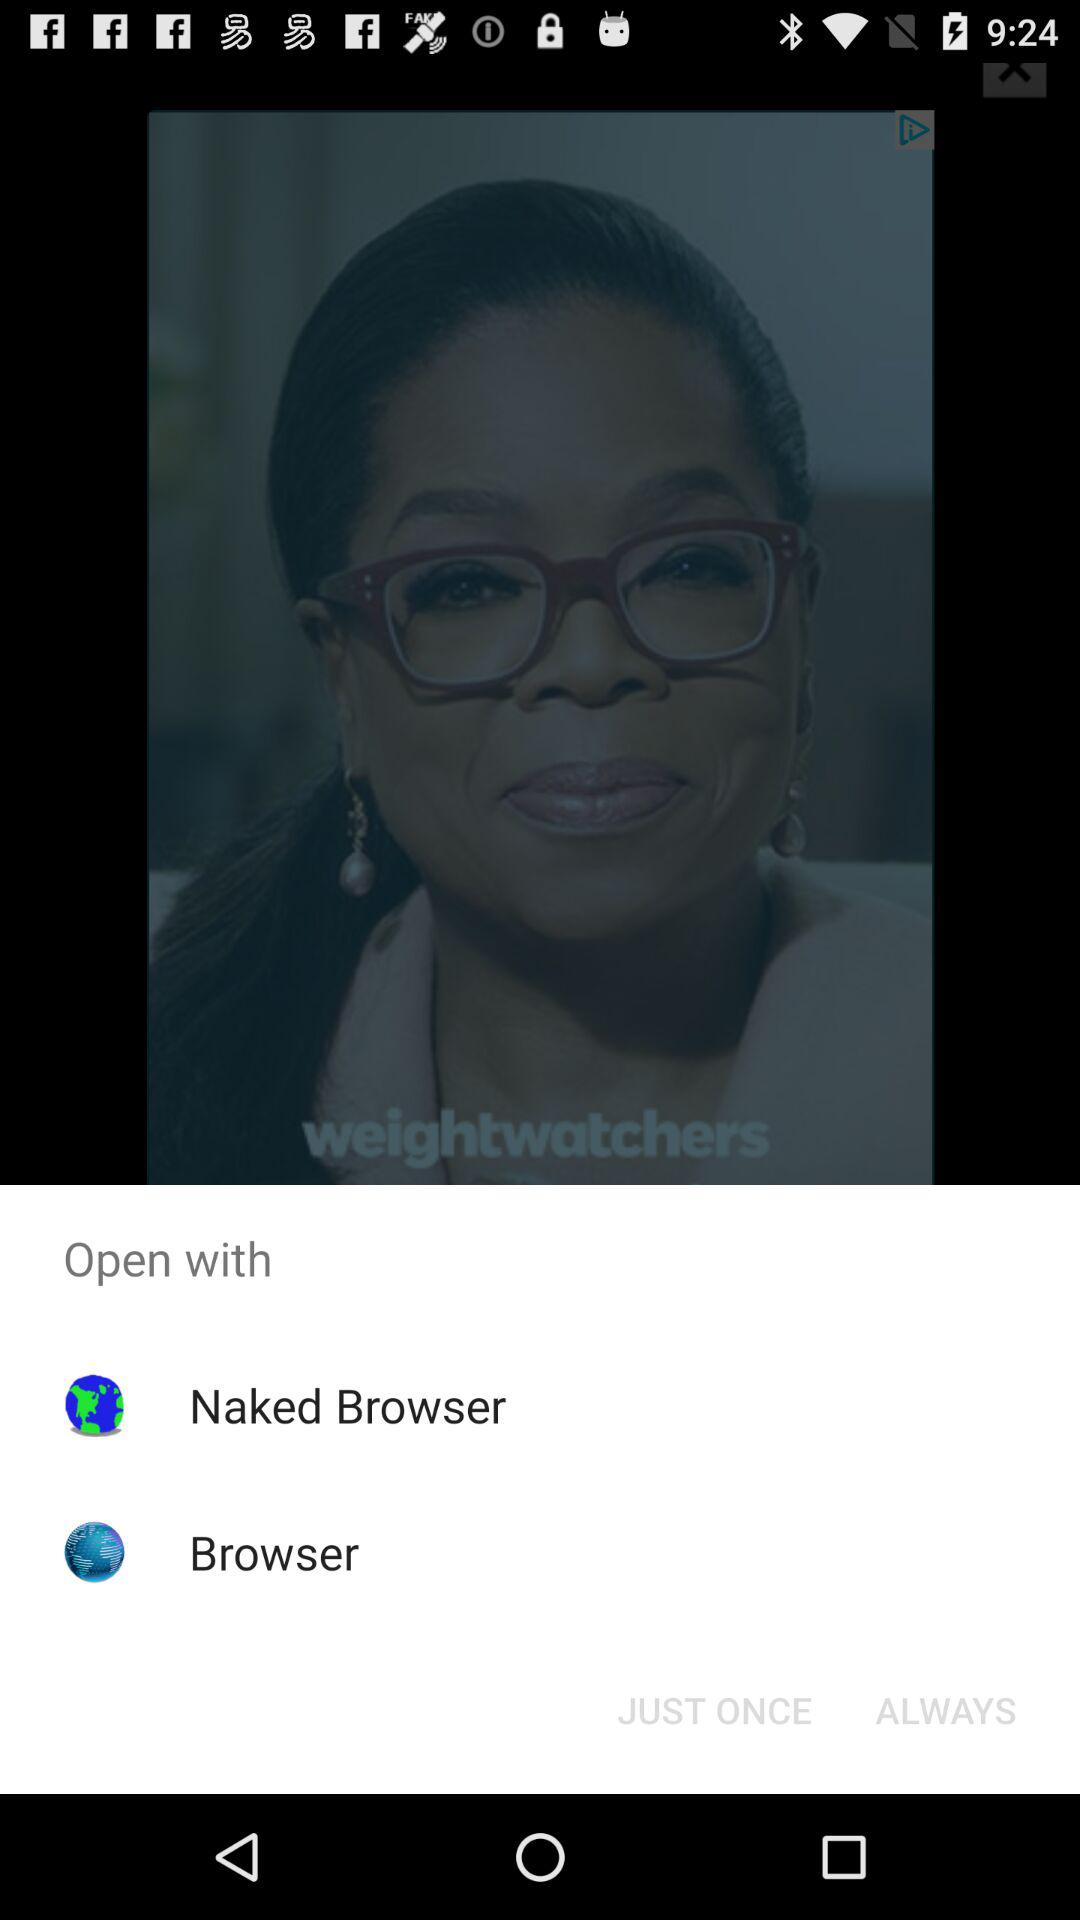What applications can be used to open it? The application is "Naked Browser". 